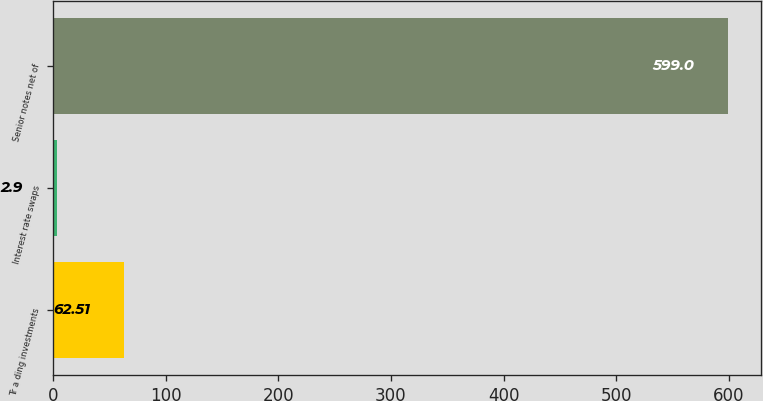Convert chart. <chart><loc_0><loc_0><loc_500><loc_500><bar_chart><fcel>Tr a ding investments<fcel>Interest rate swaps<fcel>Senior notes net of<nl><fcel>62.51<fcel>2.9<fcel>599<nl></chart> 